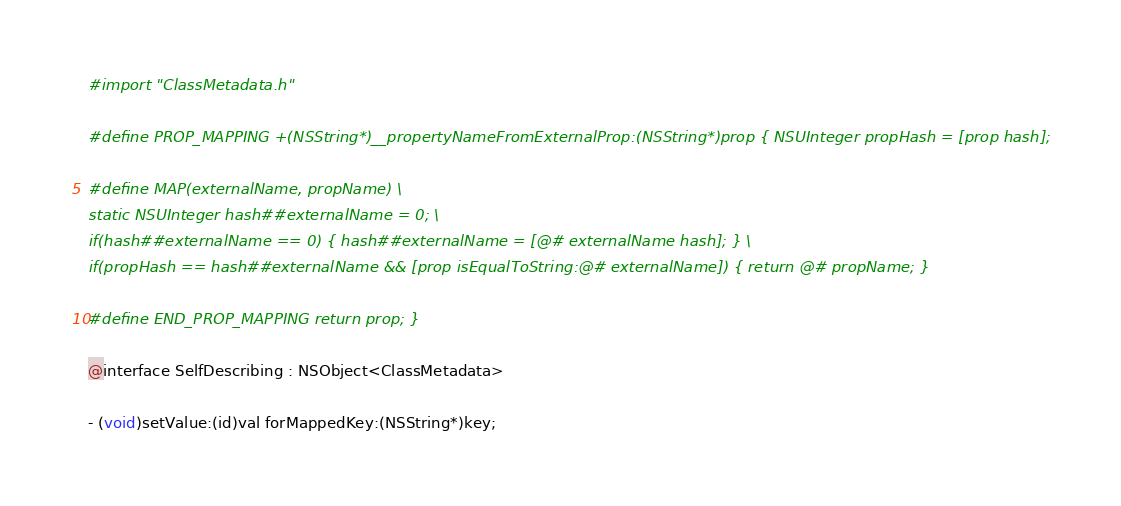<code> <loc_0><loc_0><loc_500><loc_500><_C_>#import "ClassMetadata.h"

#define PROP_MAPPING +(NSString*)__propertyNameFromExternalProp:(NSString*)prop { NSUInteger propHash = [prop hash];

#define MAP(externalName, propName) \
static NSUInteger hash##externalName = 0; \
if(hash##externalName == 0) { hash##externalName = [@# externalName hash]; } \
if(propHash == hash##externalName && [prop isEqualToString:@# externalName]) { return @# propName; }

#define END_PROP_MAPPING return prop; }

@interface SelfDescribing : NSObject<ClassMetadata>

- (void)setValue:(id)val forMappedKey:(NSString*)key;</code> 